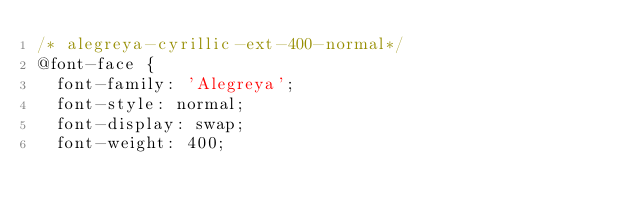<code> <loc_0><loc_0><loc_500><loc_500><_CSS_>/* alegreya-cyrillic-ext-400-normal*/
@font-face {
  font-family: 'Alegreya';
  font-style: normal;
  font-display: swap;
  font-weight: 400;</code> 